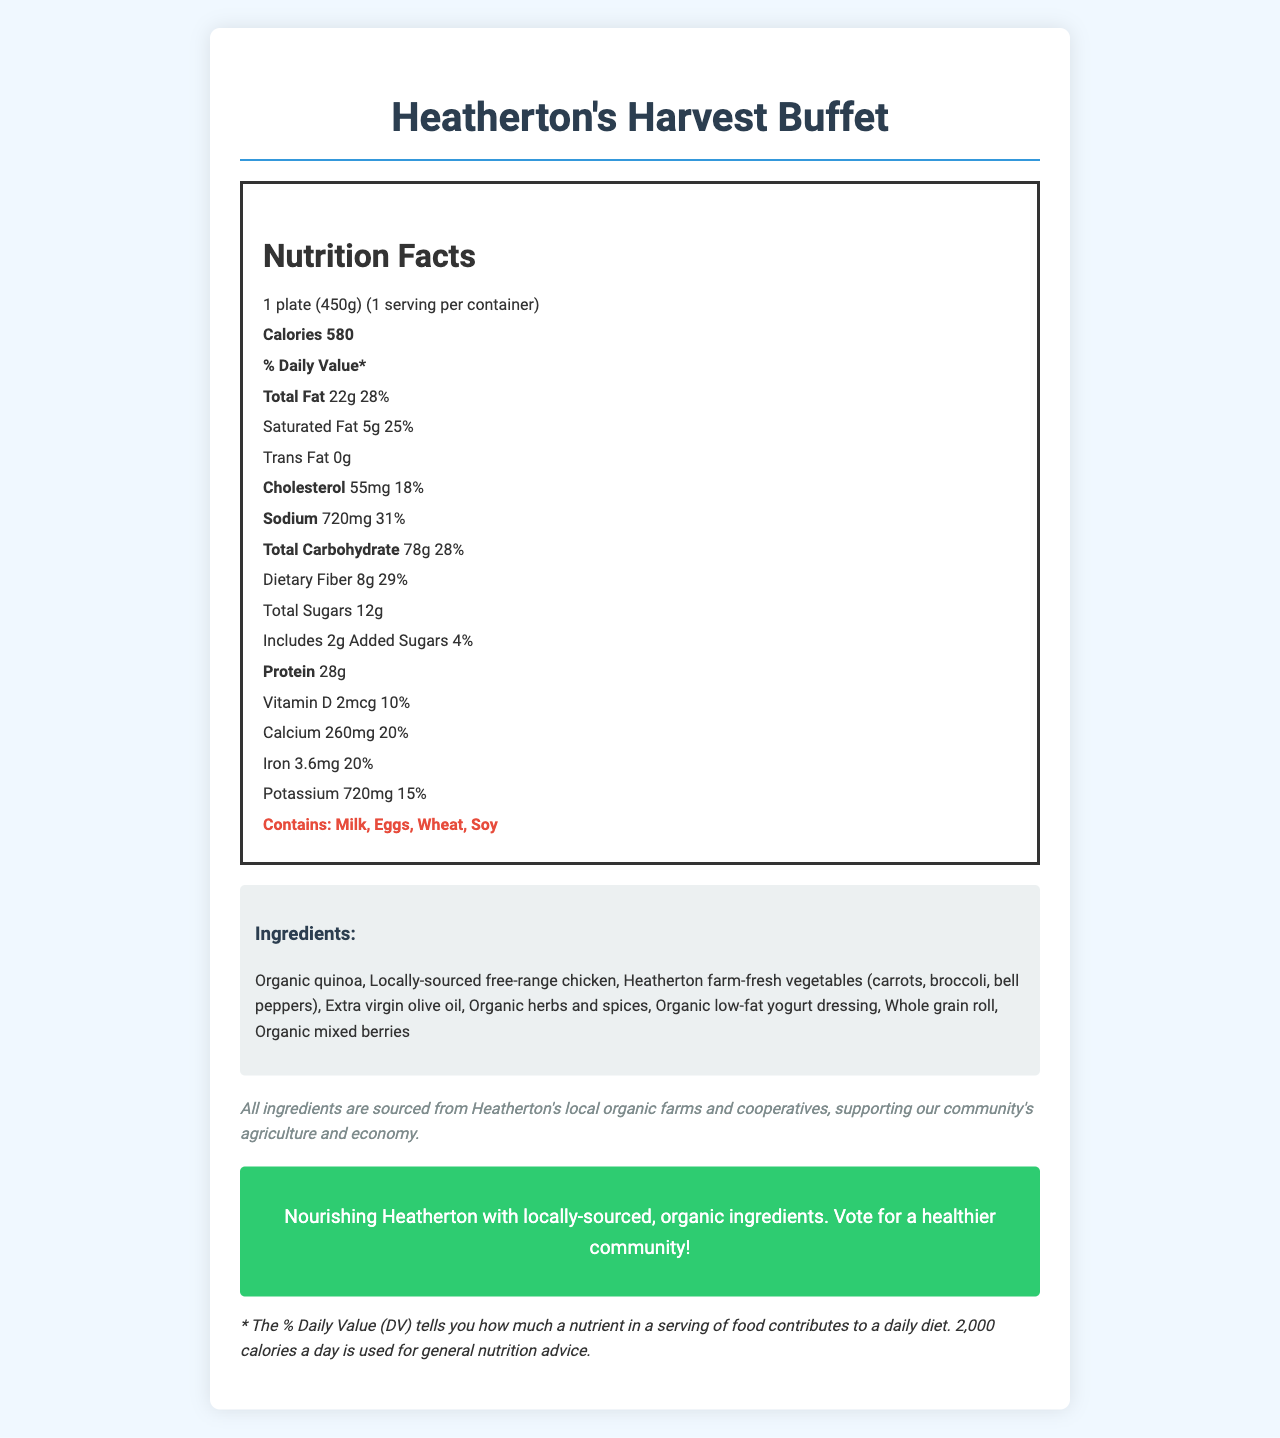what is the serving size for Heatherton's Harvest Buffet? The serving size is clearly stated as "1 plate (450g)" near the top of the document.
Answer: 1 plate (450g) how many calories are in one serving? The document lists the calories under the "Nutrition Facts" section as "Calories 580".
Answer: 580 what percentage of daily value of sodium does one serving contain? The sodium content is listed as "720 mg" which represents "31% of the daily value".
Answer: 31% how much dietary fiber is in one serving, both in grams and as a percentage of the daily value? The document states "Dietary Fiber 8g 29%".
Answer: 8g, 29% what allergens are present in this dish? The allergens are clearly listed under the allergens section: "Contains: Milk, Eggs, Wheat, Soy".
Answer: Milk, Eggs, Wheat, Soy which of the following ingredients is NOT listed in this dish: Organic quinoa, Avocados, Free-range chicken, Extra virgin olive oil? The list of ingredients does not include avocados. Instead, it includes "Organic quinoa", "Locally-sourced free-range chicken", and "Extra virgin olive oil".
Answer: Avocados how much protein is in one serving of the buffet? The document mentions "Protein 28g" in the Nutrition Facts section.
Answer: 28g what is the daily value percentage for calcium in this dish? A. 10% B. 20% C. 18% D. 25% The calcium content is mentioned as "260 mg" which represents "20% of the daily value".
Answer: B. 20% does the product contain any trans fat? The document states "Trans Fat 0g" which indicates there is no trans fat in the product.
Answer: No what is the main message of the campaign? The campaign message is explicitly stated at the bottom of the document: "Nourishing Heatherton with locally-sourced, organic ingredients. Vote for a healthier community!".
Answer: Nourishing Heatherton with locally-sourced, organic ingredients. Vote for a healthier community! where are the ingredients of this dish sourced from? The sourcing information section states that all ingredients are sourced from "Heatherton's local organic farms and cooperatives".
Answer: Heatherton's local organic farms and cooperatives describe the entire document or the main idea of the document. The document aims to offer complete nutritional information along with a clear campaign message that emphasizes the use of local, organic ingredients to nourish the community of Heatherton.
Answer: The document provides detailed Nutrition Facts for a locally-sourced, organic catering menu item called "Heatherton's Harvest Buffet". It includes information on serving size, calories, and various nutrients with their daily values. Additionally, it lists the ingredients, allergens, a campaign message promoting healthy eating and local sourcing, and information about the origin of the ingredients. who is likely the producer of this document? The document does not provide specific information on who created or produced it, only mentions resources sourced from Heatherton's local farms and cooperatives. So, the exact producer cannot be determined.
Answer: Cannot be determined is the information about the percentage of calories from fat provided? The document does not include a specific percentage of calories from fat, only the total calories and the total fat in grams along with daily value percentage.
Answer: No 